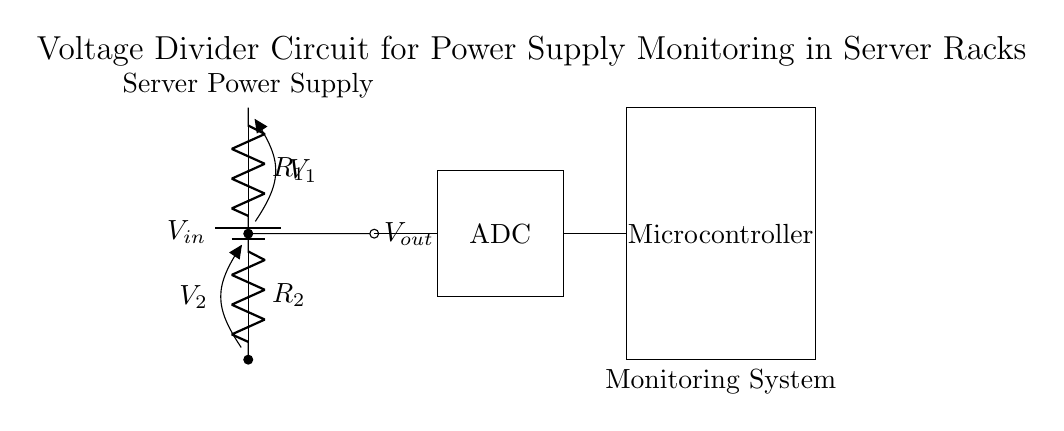What is the input voltage of the circuit? The input voltage is labeled as V-in in the circuit, which is connected to the battery symbol.
Answer: V-in What are the values of the resistors used in the voltage divider? The circuit diagram does not specify numerical values for R1 and R2, but they are both clearly labeled as resistors in the voltage divider section.
Answer: R1, R2 What is the purpose of the ADC in this circuit? The ADC (Analog-to-Digital Converter) is used to convert the analog voltage V-out from the voltage divider into a digital signal for the microcontroller to process.
Answer: Convert voltage What is the relationship between V1 and V2 in a voltage divider? In a voltage divider, the output voltage V2 is a fraction of the input voltage V-in based on the resistor values R1 and R2. The formula is V2 = V-in * (R2 / (R1 + R2)).
Answer: V2 = V-in * (R2 / (R1 + R2)) Which component monitors the output voltage? The microcontroller receives the digital value corresponding to the output voltage V-out from the ADC, thus monitoring it.
Answer: Microcontroller What does V-out represent in the circuit? V-out is the voltage measured across the second resistor R2 in the voltage divider, which is used for monitoring the power supply voltage.
Answer: Voltage across R2 What happens to V-out if R2 is significantly smaller than R1? If R2 is much smaller than R1, V-out will be very low, approaching zero volts, as most of the input voltage drops across R1.
Answer: Approaches zero volts 